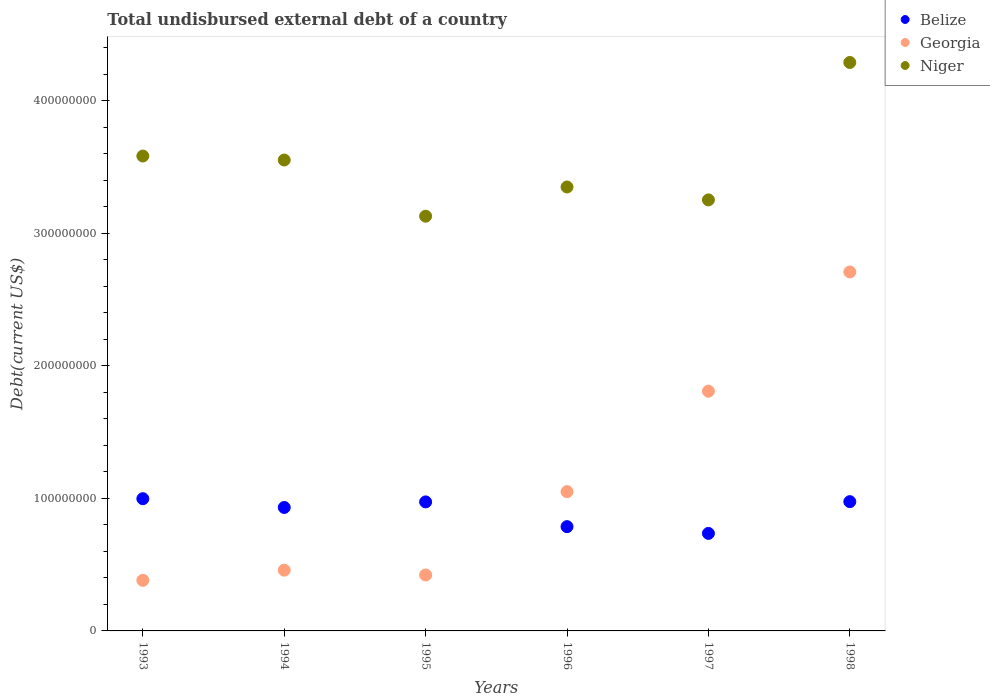How many different coloured dotlines are there?
Give a very brief answer. 3. Is the number of dotlines equal to the number of legend labels?
Provide a succinct answer. Yes. What is the total undisbursed external debt in Georgia in 1993?
Provide a short and direct response. 3.82e+07. Across all years, what is the maximum total undisbursed external debt in Georgia?
Your response must be concise. 2.71e+08. Across all years, what is the minimum total undisbursed external debt in Niger?
Keep it short and to the point. 3.13e+08. In which year was the total undisbursed external debt in Belize minimum?
Your answer should be compact. 1997. What is the total total undisbursed external debt in Belize in the graph?
Your answer should be compact. 5.40e+08. What is the difference between the total undisbursed external debt in Niger in 1995 and that in 1996?
Give a very brief answer. -2.20e+07. What is the difference between the total undisbursed external debt in Belize in 1998 and the total undisbursed external debt in Niger in 1996?
Your answer should be compact. -2.37e+08. What is the average total undisbursed external debt in Georgia per year?
Provide a short and direct response. 1.14e+08. In the year 1996, what is the difference between the total undisbursed external debt in Georgia and total undisbursed external debt in Niger?
Offer a terse response. -2.30e+08. What is the ratio of the total undisbursed external debt in Niger in 1996 to that in 1998?
Offer a very short reply. 0.78. What is the difference between the highest and the second highest total undisbursed external debt in Georgia?
Make the answer very short. 8.99e+07. What is the difference between the highest and the lowest total undisbursed external debt in Belize?
Ensure brevity in your answer.  2.62e+07. Is the sum of the total undisbursed external debt in Belize in 1997 and 1998 greater than the maximum total undisbursed external debt in Niger across all years?
Offer a terse response. No. Is the total undisbursed external debt in Belize strictly greater than the total undisbursed external debt in Niger over the years?
Provide a short and direct response. No. Is the total undisbursed external debt in Georgia strictly less than the total undisbursed external debt in Niger over the years?
Your answer should be compact. Yes. What is the difference between two consecutive major ticks on the Y-axis?
Ensure brevity in your answer.  1.00e+08. Does the graph contain any zero values?
Your response must be concise. No. How many legend labels are there?
Make the answer very short. 3. How are the legend labels stacked?
Offer a terse response. Vertical. What is the title of the graph?
Offer a terse response. Total undisbursed external debt of a country. Does "European Union" appear as one of the legend labels in the graph?
Offer a terse response. No. What is the label or title of the X-axis?
Offer a very short reply. Years. What is the label or title of the Y-axis?
Keep it short and to the point. Debt(current US$). What is the Debt(current US$) of Belize in 1993?
Keep it short and to the point. 9.97e+07. What is the Debt(current US$) in Georgia in 1993?
Offer a very short reply. 3.82e+07. What is the Debt(current US$) of Niger in 1993?
Offer a terse response. 3.58e+08. What is the Debt(current US$) in Belize in 1994?
Keep it short and to the point. 9.31e+07. What is the Debt(current US$) of Georgia in 1994?
Offer a very short reply. 4.58e+07. What is the Debt(current US$) in Niger in 1994?
Provide a short and direct response. 3.55e+08. What is the Debt(current US$) in Belize in 1995?
Provide a short and direct response. 9.73e+07. What is the Debt(current US$) in Georgia in 1995?
Make the answer very short. 4.22e+07. What is the Debt(current US$) of Niger in 1995?
Your answer should be very brief. 3.13e+08. What is the Debt(current US$) of Belize in 1996?
Offer a terse response. 7.87e+07. What is the Debt(current US$) in Georgia in 1996?
Provide a short and direct response. 1.05e+08. What is the Debt(current US$) of Niger in 1996?
Ensure brevity in your answer.  3.35e+08. What is the Debt(current US$) in Belize in 1997?
Give a very brief answer. 7.35e+07. What is the Debt(current US$) in Georgia in 1997?
Your answer should be very brief. 1.81e+08. What is the Debt(current US$) in Niger in 1997?
Offer a very short reply. 3.25e+08. What is the Debt(current US$) of Belize in 1998?
Make the answer very short. 9.75e+07. What is the Debt(current US$) in Georgia in 1998?
Ensure brevity in your answer.  2.71e+08. What is the Debt(current US$) of Niger in 1998?
Provide a short and direct response. 4.29e+08. Across all years, what is the maximum Debt(current US$) in Belize?
Give a very brief answer. 9.97e+07. Across all years, what is the maximum Debt(current US$) in Georgia?
Ensure brevity in your answer.  2.71e+08. Across all years, what is the maximum Debt(current US$) of Niger?
Your answer should be very brief. 4.29e+08. Across all years, what is the minimum Debt(current US$) in Belize?
Your answer should be compact. 7.35e+07. Across all years, what is the minimum Debt(current US$) in Georgia?
Offer a terse response. 3.82e+07. Across all years, what is the minimum Debt(current US$) in Niger?
Your answer should be very brief. 3.13e+08. What is the total Debt(current US$) in Belize in the graph?
Your answer should be compact. 5.40e+08. What is the total Debt(current US$) of Georgia in the graph?
Provide a succinct answer. 6.83e+08. What is the total Debt(current US$) in Niger in the graph?
Give a very brief answer. 2.11e+09. What is the difference between the Debt(current US$) of Belize in 1993 and that in 1994?
Make the answer very short. 6.62e+06. What is the difference between the Debt(current US$) of Georgia in 1993 and that in 1994?
Ensure brevity in your answer.  -7.67e+06. What is the difference between the Debt(current US$) in Niger in 1993 and that in 1994?
Offer a very short reply. 3.01e+06. What is the difference between the Debt(current US$) of Belize in 1993 and that in 1995?
Your response must be concise. 2.42e+06. What is the difference between the Debt(current US$) of Georgia in 1993 and that in 1995?
Provide a short and direct response. -4.03e+06. What is the difference between the Debt(current US$) in Niger in 1993 and that in 1995?
Give a very brief answer. 4.54e+07. What is the difference between the Debt(current US$) in Belize in 1993 and that in 1996?
Ensure brevity in your answer.  2.11e+07. What is the difference between the Debt(current US$) in Georgia in 1993 and that in 1996?
Your answer should be very brief. -6.69e+07. What is the difference between the Debt(current US$) of Niger in 1993 and that in 1996?
Ensure brevity in your answer.  2.34e+07. What is the difference between the Debt(current US$) in Belize in 1993 and that in 1997?
Keep it short and to the point. 2.62e+07. What is the difference between the Debt(current US$) in Georgia in 1993 and that in 1997?
Keep it short and to the point. -1.43e+08. What is the difference between the Debt(current US$) in Niger in 1993 and that in 1997?
Keep it short and to the point. 3.31e+07. What is the difference between the Debt(current US$) in Belize in 1993 and that in 1998?
Make the answer very short. 2.23e+06. What is the difference between the Debt(current US$) in Georgia in 1993 and that in 1998?
Offer a terse response. -2.33e+08. What is the difference between the Debt(current US$) of Niger in 1993 and that in 1998?
Your answer should be compact. -7.06e+07. What is the difference between the Debt(current US$) of Belize in 1994 and that in 1995?
Your answer should be very brief. -4.20e+06. What is the difference between the Debt(current US$) of Georgia in 1994 and that in 1995?
Offer a very short reply. 3.64e+06. What is the difference between the Debt(current US$) of Niger in 1994 and that in 1995?
Provide a succinct answer. 4.24e+07. What is the difference between the Debt(current US$) of Belize in 1994 and that in 1996?
Provide a short and direct response. 1.45e+07. What is the difference between the Debt(current US$) of Georgia in 1994 and that in 1996?
Provide a short and direct response. -5.92e+07. What is the difference between the Debt(current US$) in Niger in 1994 and that in 1996?
Keep it short and to the point. 2.03e+07. What is the difference between the Debt(current US$) of Belize in 1994 and that in 1997?
Offer a very short reply. 1.96e+07. What is the difference between the Debt(current US$) of Georgia in 1994 and that in 1997?
Offer a terse response. -1.35e+08. What is the difference between the Debt(current US$) in Niger in 1994 and that in 1997?
Give a very brief answer. 3.01e+07. What is the difference between the Debt(current US$) in Belize in 1994 and that in 1998?
Offer a very short reply. -4.39e+06. What is the difference between the Debt(current US$) of Georgia in 1994 and that in 1998?
Give a very brief answer. -2.25e+08. What is the difference between the Debt(current US$) in Niger in 1994 and that in 1998?
Ensure brevity in your answer.  -7.36e+07. What is the difference between the Debt(current US$) of Belize in 1995 and that in 1996?
Your answer should be compact. 1.87e+07. What is the difference between the Debt(current US$) of Georgia in 1995 and that in 1996?
Provide a short and direct response. -6.29e+07. What is the difference between the Debt(current US$) in Niger in 1995 and that in 1996?
Provide a succinct answer. -2.20e+07. What is the difference between the Debt(current US$) in Belize in 1995 and that in 1997?
Provide a succinct answer. 2.38e+07. What is the difference between the Debt(current US$) of Georgia in 1995 and that in 1997?
Offer a very short reply. -1.39e+08. What is the difference between the Debt(current US$) in Niger in 1995 and that in 1997?
Provide a short and direct response. -1.23e+07. What is the difference between the Debt(current US$) of Belize in 1995 and that in 1998?
Your response must be concise. -1.91e+05. What is the difference between the Debt(current US$) in Georgia in 1995 and that in 1998?
Provide a succinct answer. -2.29e+08. What is the difference between the Debt(current US$) in Niger in 1995 and that in 1998?
Provide a short and direct response. -1.16e+08. What is the difference between the Debt(current US$) in Belize in 1996 and that in 1997?
Offer a terse response. 5.10e+06. What is the difference between the Debt(current US$) in Georgia in 1996 and that in 1997?
Your answer should be compact. -7.58e+07. What is the difference between the Debt(current US$) in Niger in 1996 and that in 1997?
Give a very brief answer. 9.73e+06. What is the difference between the Debt(current US$) of Belize in 1996 and that in 1998?
Ensure brevity in your answer.  -1.89e+07. What is the difference between the Debt(current US$) of Georgia in 1996 and that in 1998?
Your response must be concise. -1.66e+08. What is the difference between the Debt(current US$) of Niger in 1996 and that in 1998?
Keep it short and to the point. -9.39e+07. What is the difference between the Debt(current US$) in Belize in 1997 and that in 1998?
Ensure brevity in your answer.  -2.40e+07. What is the difference between the Debt(current US$) of Georgia in 1997 and that in 1998?
Offer a very short reply. -8.99e+07. What is the difference between the Debt(current US$) in Niger in 1997 and that in 1998?
Your response must be concise. -1.04e+08. What is the difference between the Debt(current US$) of Belize in 1993 and the Debt(current US$) of Georgia in 1994?
Offer a terse response. 5.39e+07. What is the difference between the Debt(current US$) of Belize in 1993 and the Debt(current US$) of Niger in 1994?
Ensure brevity in your answer.  -2.55e+08. What is the difference between the Debt(current US$) in Georgia in 1993 and the Debt(current US$) in Niger in 1994?
Offer a very short reply. -3.17e+08. What is the difference between the Debt(current US$) in Belize in 1993 and the Debt(current US$) in Georgia in 1995?
Keep it short and to the point. 5.75e+07. What is the difference between the Debt(current US$) in Belize in 1993 and the Debt(current US$) in Niger in 1995?
Give a very brief answer. -2.13e+08. What is the difference between the Debt(current US$) of Georgia in 1993 and the Debt(current US$) of Niger in 1995?
Keep it short and to the point. -2.75e+08. What is the difference between the Debt(current US$) of Belize in 1993 and the Debt(current US$) of Georgia in 1996?
Provide a short and direct response. -5.31e+06. What is the difference between the Debt(current US$) of Belize in 1993 and the Debt(current US$) of Niger in 1996?
Your answer should be compact. -2.35e+08. What is the difference between the Debt(current US$) of Georgia in 1993 and the Debt(current US$) of Niger in 1996?
Make the answer very short. -2.97e+08. What is the difference between the Debt(current US$) of Belize in 1993 and the Debt(current US$) of Georgia in 1997?
Provide a succinct answer. -8.11e+07. What is the difference between the Debt(current US$) of Belize in 1993 and the Debt(current US$) of Niger in 1997?
Offer a very short reply. -2.25e+08. What is the difference between the Debt(current US$) of Georgia in 1993 and the Debt(current US$) of Niger in 1997?
Your response must be concise. -2.87e+08. What is the difference between the Debt(current US$) of Belize in 1993 and the Debt(current US$) of Georgia in 1998?
Give a very brief answer. -1.71e+08. What is the difference between the Debt(current US$) in Belize in 1993 and the Debt(current US$) in Niger in 1998?
Offer a very short reply. -3.29e+08. What is the difference between the Debt(current US$) of Georgia in 1993 and the Debt(current US$) of Niger in 1998?
Make the answer very short. -3.91e+08. What is the difference between the Debt(current US$) in Belize in 1994 and the Debt(current US$) in Georgia in 1995?
Make the answer very short. 5.09e+07. What is the difference between the Debt(current US$) of Belize in 1994 and the Debt(current US$) of Niger in 1995?
Offer a terse response. -2.20e+08. What is the difference between the Debt(current US$) in Georgia in 1994 and the Debt(current US$) in Niger in 1995?
Your answer should be very brief. -2.67e+08. What is the difference between the Debt(current US$) of Belize in 1994 and the Debt(current US$) of Georgia in 1996?
Offer a very short reply. -1.19e+07. What is the difference between the Debt(current US$) of Belize in 1994 and the Debt(current US$) of Niger in 1996?
Offer a terse response. -2.42e+08. What is the difference between the Debt(current US$) in Georgia in 1994 and the Debt(current US$) in Niger in 1996?
Give a very brief answer. -2.89e+08. What is the difference between the Debt(current US$) of Belize in 1994 and the Debt(current US$) of Georgia in 1997?
Offer a terse response. -8.77e+07. What is the difference between the Debt(current US$) of Belize in 1994 and the Debt(current US$) of Niger in 1997?
Keep it short and to the point. -2.32e+08. What is the difference between the Debt(current US$) in Georgia in 1994 and the Debt(current US$) in Niger in 1997?
Offer a very short reply. -2.79e+08. What is the difference between the Debt(current US$) of Belize in 1994 and the Debt(current US$) of Georgia in 1998?
Keep it short and to the point. -1.78e+08. What is the difference between the Debt(current US$) of Belize in 1994 and the Debt(current US$) of Niger in 1998?
Offer a very short reply. -3.36e+08. What is the difference between the Debt(current US$) in Georgia in 1994 and the Debt(current US$) in Niger in 1998?
Provide a succinct answer. -3.83e+08. What is the difference between the Debt(current US$) in Belize in 1995 and the Debt(current US$) in Georgia in 1996?
Provide a succinct answer. -7.73e+06. What is the difference between the Debt(current US$) in Belize in 1995 and the Debt(current US$) in Niger in 1996?
Ensure brevity in your answer.  -2.38e+08. What is the difference between the Debt(current US$) in Georgia in 1995 and the Debt(current US$) in Niger in 1996?
Offer a very short reply. -2.93e+08. What is the difference between the Debt(current US$) of Belize in 1995 and the Debt(current US$) of Georgia in 1997?
Your response must be concise. -8.35e+07. What is the difference between the Debt(current US$) of Belize in 1995 and the Debt(current US$) of Niger in 1997?
Give a very brief answer. -2.28e+08. What is the difference between the Debt(current US$) in Georgia in 1995 and the Debt(current US$) in Niger in 1997?
Provide a succinct answer. -2.83e+08. What is the difference between the Debt(current US$) of Belize in 1995 and the Debt(current US$) of Georgia in 1998?
Make the answer very short. -1.73e+08. What is the difference between the Debt(current US$) in Belize in 1995 and the Debt(current US$) in Niger in 1998?
Ensure brevity in your answer.  -3.31e+08. What is the difference between the Debt(current US$) in Georgia in 1995 and the Debt(current US$) in Niger in 1998?
Your response must be concise. -3.87e+08. What is the difference between the Debt(current US$) of Belize in 1996 and the Debt(current US$) of Georgia in 1997?
Your answer should be very brief. -1.02e+08. What is the difference between the Debt(current US$) in Belize in 1996 and the Debt(current US$) in Niger in 1997?
Your answer should be very brief. -2.46e+08. What is the difference between the Debt(current US$) in Georgia in 1996 and the Debt(current US$) in Niger in 1997?
Give a very brief answer. -2.20e+08. What is the difference between the Debt(current US$) of Belize in 1996 and the Debt(current US$) of Georgia in 1998?
Your response must be concise. -1.92e+08. What is the difference between the Debt(current US$) of Belize in 1996 and the Debt(current US$) of Niger in 1998?
Ensure brevity in your answer.  -3.50e+08. What is the difference between the Debt(current US$) in Georgia in 1996 and the Debt(current US$) in Niger in 1998?
Ensure brevity in your answer.  -3.24e+08. What is the difference between the Debt(current US$) in Belize in 1997 and the Debt(current US$) in Georgia in 1998?
Provide a succinct answer. -1.97e+08. What is the difference between the Debt(current US$) in Belize in 1997 and the Debt(current US$) in Niger in 1998?
Your answer should be compact. -3.55e+08. What is the difference between the Debt(current US$) in Georgia in 1997 and the Debt(current US$) in Niger in 1998?
Your answer should be very brief. -2.48e+08. What is the average Debt(current US$) of Belize per year?
Your answer should be very brief. 9.00e+07. What is the average Debt(current US$) in Georgia per year?
Provide a succinct answer. 1.14e+08. What is the average Debt(current US$) in Niger per year?
Offer a terse response. 3.52e+08. In the year 1993, what is the difference between the Debt(current US$) of Belize and Debt(current US$) of Georgia?
Give a very brief answer. 6.16e+07. In the year 1993, what is the difference between the Debt(current US$) in Belize and Debt(current US$) in Niger?
Your answer should be very brief. -2.58e+08. In the year 1993, what is the difference between the Debt(current US$) of Georgia and Debt(current US$) of Niger?
Provide a succinct answer. -3.20e+08. In the year 1994, what is the difference between the Debt(current US$) of Belize and Debt(current US$) of Georgia?
Offer a very short reply. 4.73e+07. In the year 1994, what is the difference between the Debt(current US$) of Belize and Debt(current US$) of Niger?
Offer a very short reply. -2.62e+08. In the year 1994, what is the difference between the Debt(current US$) in Georgia and Debt(current US$) in Niger?
Offer a very short reply. -3.09e+08. In the year 1995, what is the difference between the Debt(current US$) of Belize and Debt(current US$) of Georgia?
Keep it short and to the point. 5.51e+07. In the year 1995, what is the difference between the Debt(current US$) of Belize and Debt(current US$) of Niger?
Your response must be concise. -2.16e+08. In the year 1995, what is the difference between the Debt(current US$) of Georgia and Debt(current US$) of Niger?
Offer a very short reply. -2.71e+08. In the year 1996, what is the difference between the Debt(current US$) in Belize and Debt(current US$) in Georgia?
Your answer should be very brief. -2.64e+07. In the year 1996, what is the difference between the Debt(current US$) of Belize and Debt(current US$) of Niger?
Keep it short and to the point. -2.56e+08. In the year 1996, what is the difference between the Debt(current US$) of Georgia and Debt(current US$) of Niger?
Your answer should be very brief. -2.30e+08. In the year 1997, what is the difference between the Debt(current US$) in Belize and Debt(current US$) in Georgia?
Provide a succinct answer. -1.07e+08. In the year 1997, what is the difference between the Debt(current US$) of Belize and Debt(current US$) of Niger?
Provide a short and direct response. -2.52e+08. In the year 1997, what is the difference between the Debt(current US$) in Georgia and Debt(current US$) in Niger?
Offer a very short reply. -1.44e+08. In the year 1998, what is the difference between the Debt(current US$) of Belize and Debt(current US$) of Georgia?
Your answer should be very brief. -1.73e+08. In the year 1998, what is the difference between the Debt(current US$) of Belize and Debt(current US$) of Niger?
Your response must be concise. -3.31e+08. In the year 1998, what is the difference between the Debt(current US$) of Georgia and Debt(current US$) of Niger?
Provide a succinct answer. -1.58e+08. What is the ratio of the Debt(current US$) of Belize in 1993 to that in 1994?
Provide a short and direct response. 1.07. What is the ratio of the Debt(current US$) in Georgia in 1993 to that in 1994?
Make the answer very short. 0.83. What is the ratio of the Debt(current US$) in Niger in 1993 to that in 1994?
Your answer should be compact. 1.01. What is the ratio of the Debt(current US$) of Belize in 1993 to that in 1995?
Provide a short and direct response. 1.02. What is the ratio of the Debt(current US$) in Georgia in 1993 to that in 1995?
Your answer should be compact. 0.9. What is the ratio of the Debt(current US$) in Niger in 1993 to that in 1995?
Provide a succinct answer. 1.15. What is the ratio of the Debt(current US$) in Belize in 1993 to that in 1996?
Offer a very short reply. 1.27. What is the ratio of the Debt(current US$) of Georgia in 1993 to that in 1996?
Offer a very short reply. 0.36. What is the ratio of the Debt(current US$) in Niger in 1993 to that in 1996?
Offer a very short reply. 1.07. What is the ratio of the Debt(current US$) of Belize in 1993 to that in 1997?
Your answer should be very brief. 1.36. What is the ratio of the Debt(current US$) in Georgia in 1993 to that in 1997?
Your answer should be very brief. 0.21. What is the ratio of the Debt(current US$) in Niger in 1993 to that in 1997?
Make the answer very short. 1.1. What is the ratio of the Debt(current US$) in Belize in 1993 to that in 1998?
Offer a very short reply. 1.02. What is the ratio of the Debt(current US$) in Georgia in 1993 to that in 1998?
Your answer should be very brief. 0.14. What is the ratio of the Debt(current US$) in Niger in 1993 to that in 1998?
Provide a succinct answer. 0.84. What is the ratio of the Debt(current US$) in Belize in 1994 to that in 1995?
Provide a succinct answer. 0.96. What is the ratio of the Debt(current US$) in Georgia in 1994 to that in 1995?
Your response must be concise. 1.09. What is the ratio of the Debt(current US$) of Niger in 1994 to that in 1995?
Give a very brief answer. 1.14. What is the ratio of the Debt(current US$) in Belize in 1994 to that in 1996?
Your answer should be very brief. 1.18. What is the ratio of the Debt(current US$) in Georgia in 1994 to that in 1996?
Make the answer very short. 0.44. What is the ratio of the Debt(current US$) of Niger in 1994 to that in 1996?
Your response must be concise. 1.06. What is the ratio of the Debt(current US$) in Belize in 1994 to that in 1997?
Offer a terse response. 1.27. What is the ratio of the Debt(current US$) in Georgia in 1994 to that in 1997?
Ensure brevity in your answer.  0.25. What is the ratio of the Debt(current US$) in Niger in 1994 to that in 1997?
Your response must be concise. 1.09. What is the ratio of the Debt(current US$) in Belize in 1994 to that in 1998?
Your answer should be very brief. 0.95. What is the ratio of the Debt(current US$) in Georgia in 1994 to that in 1998?
Provide a short and direct response. 0.17. What is the ratio of the Debt(current US$) in Niger in 1994 to that in 1998?
Keep it short and to the point. 0.83. What is the ratio of the Debt(current US$) in Belize in 1995 to that in 1996?
Your answer should be compact. 1.24. What is the ratio of the Debt(current US$) in Georgia in 1995 to that in 1996?
Offer a terse response. 0.4. What is the ratio of the Debt(current US$) in Niger in 1995 to that in 1996?
Provide a short and direct response. 0.93. What is the ratio of the Debt(current US$) of Belize in 1995 to that in 1997?
Offer a very short reply. 1.32. What is the ratio of the Debt(current US$) of Georgia in 1995 to that in 1997?
Give a very brief answer. 0.23. What is the ratio of the Debt(current US$) of Niger in 1995 to that in 1997?
Provide a short and direct response. 0.96. What is the ratio of the Debt(current US$) of Belize in 1995 to that in 1998?
Your answer should be compact. 1. What is the ratio of the Debt(current US$) of Georgia in 1995 to that in 1998?
Your answer should be compact. 0.16. What is the ratio of the Debt(current US$) in Niger in 1995 to that in 1998?
Your answer should be compact. 0.73. What is the ratio of the Debt(current US$) of Belize in 1996 to that in 1997?
Keep it short and to the point. 1.07. What is the ratio of the Debt(current US$) of Georgia in 1996 to that in 1997?
Provide a succinct answer. 0.58. What is the ratio of the Debt(current US$) of Niger in 1996 to that in 1997?
Your answer should be very brief. 1.03. What is the ratio of the Debt(current US$) of Belize in 1996 to that in 1998?
Ensure brevity in your answer.  0.81. What is the ratio of the Debt(current US$) in Georgia in 1996 to that in 1998?
Ensure brevity in your answer.  0.39. What is the ratio of the Debt(current US$) of Niger in 1996 to that in 1998?
Offer a terse response. 0.78. What is the ratio of the Debt(current US$) of Belize in 1997 to that in 1998?
Provide a short and direct response. 0.75. What is the ratio of the Debt(current US$) in Georgia in 1997 to that in 1998?
Your answer should be very brief. 0.67. What is the ratio of the Debt(current US$) of Niger in 1997 to that in 1998?
Offer a very short reply. 0.76. What is the difference between the highest and the second highest Debt(current US$) of Belize?
Give a very brief answer. 2.23e+06. What is the difference between the highest and the second highest Debt(current US$) in Georgia?
Offer a terse response. 8.99e+07. What is the difference between the highest and the second highest Debt(current US$) of Niger?
Your answer should be very brief. 7.06e+07. What is the difference between the highest and the lowest Debt(current US$) in Belize?
Keep it short and to the point. 2.62e+07. What is the difference between the highest and the lowest Debt(current US$) of Georgia?
Offer a terse response. 2.33e+08. What is the difference between the highest and the lowest Debt(current US$) of Niger?
Keep it short and to the point. 1.16e+08. 